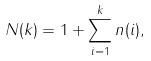Convert formula to latex. <formula><loc_0><loc_0><loc_500><loc_500>N ( k ) = 1 + \sum _ { i = 1 } ^ { k } n ( i ) ,</formula> 